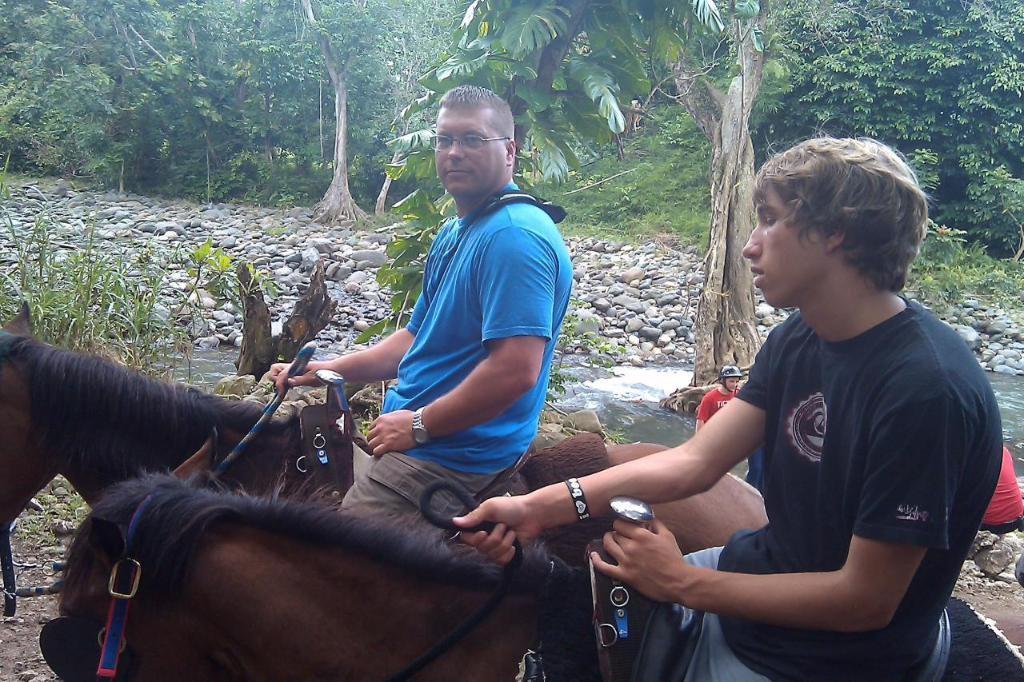How many people are in the image? There are two persons in the image. What are the two persons doing in the image? The two persons are sitting on a horse. What can be seen in the background of the image? There is a tree, stones, and water visible in the background of the image. Are there any other people in the image besides the two sitting on the horse? Yes, there are additional persons in the background of the image. What type of crack can be seen in the image? There is no crack present in the image. What are the sticks used for in the image? There are no sticks present in the image. 